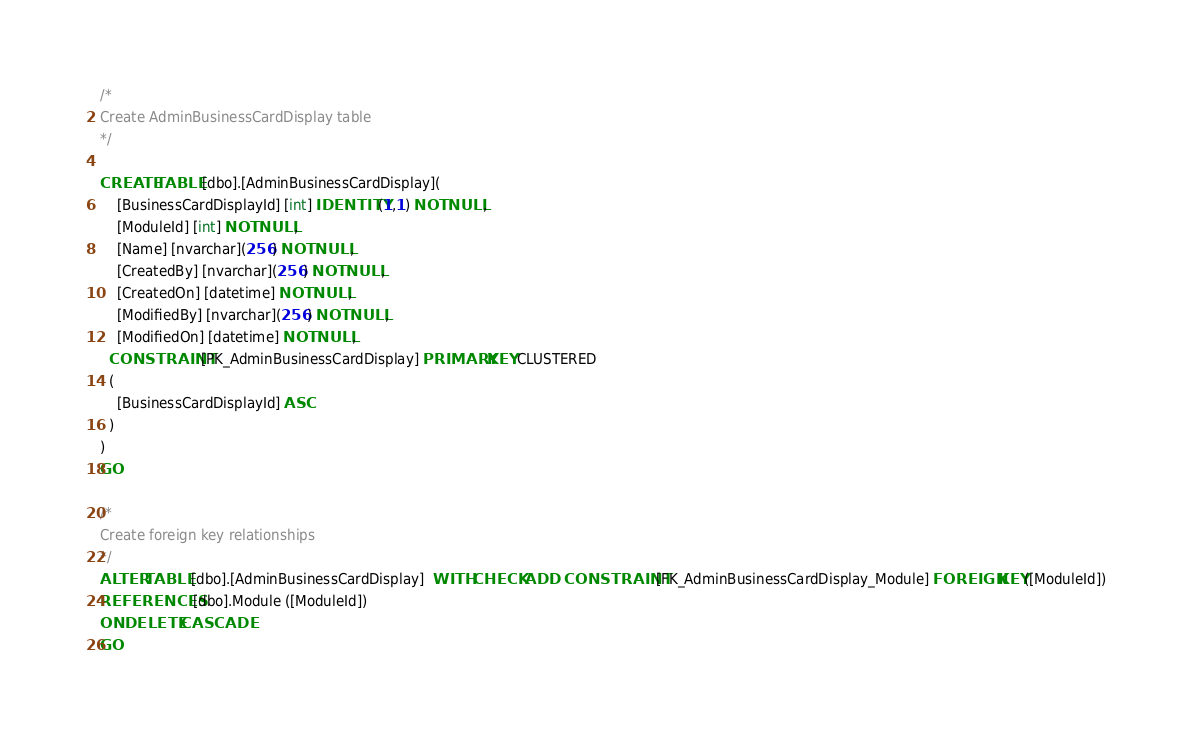<code> <loc_0><loc_0><loc_500><loc_500><_SQL_>/*  
Create AdminBusinessCardDisplay table
*/

CREATE TABLE [dbo].[AdminBusinessCardDisplay](
	[BusinessCardDisplayId] [int] IDENTITY(1,1) NOT NULL,
	[ModuleId] [int] NOT NULL,
	[Name] [nvarchar](256) NOT NULL,
	[CreatedBy] [nvarchar](256) NOT NULL,
	[CreatedOn] [datetime] NOT NULL,
	[ModifiedBy] [nvarchar](256) NOT NULL,
	[ModifiedOn] [datetime] NOT NULL,
  CONSTRAINT [PK_AdminBusinessCardDisplay] PRIMARY KEY CLUSTERED 
  (
	[BusinessCardDisplayId] ASC
  )
)
GO

/*  
Create foreign key relationships
*/
ALTER TABLE [dbo].[AdminBusinessCardDisplay]  WITH CHECK ADD  CONSTRAINT [FK_AdminBusinessCardDisplay_Module] FOREIGN KEY([ModuleId])
REFERENCES [dbo].Module ([ModuleId])
ON DELETE CASCADE
GO</code> 